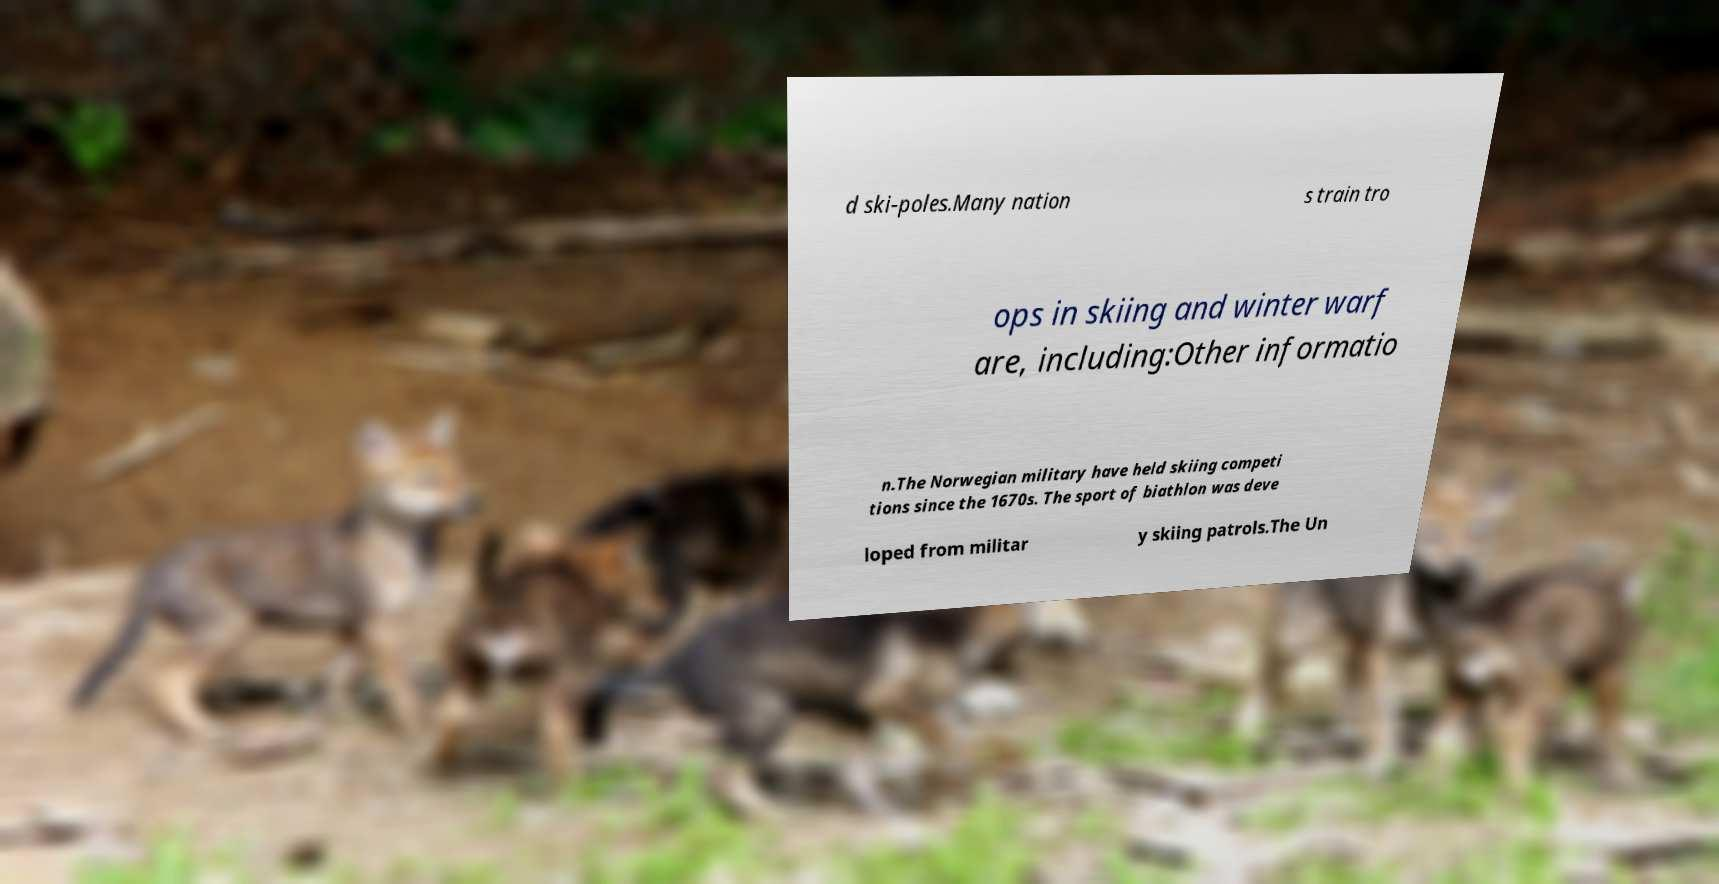I need the written content from this picture converted into text. Can you do that? d ski-poles.Many nation s train tro ops in skiing and winter warf are, including:Other informatio n.The Norwegian military have held skiing competi tions since the 1670s. The sport of biathlon was deve loped from militar y skiing patrols.The Un 